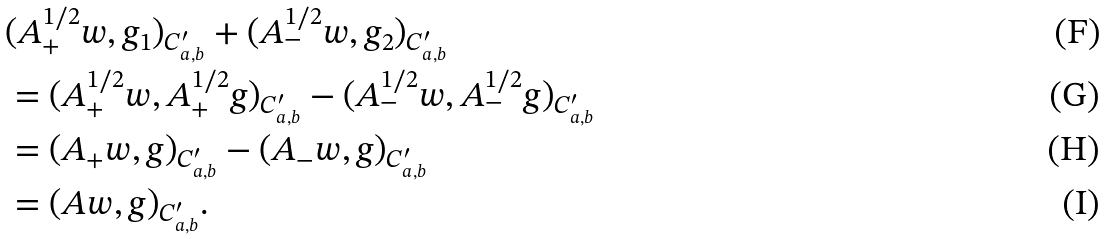<formula> <loc_0><loc_0><loc_500><loc_500>& ( A _ { + } ^ { 1 / 2 } w , g _ { 1 } ) _ { C _ { a , b } ^ { \prime } } + ( A _ { - } ^ { 1 / 2 } w , g _ { 2 } ) _ { C _ { a , b } ^ { \prime } } \\ & = ( A _ { + } ^ { 1 / 2 } w , A _ { + } ^ { 1 / 2 } g ) _ { C _ { a , b } ^ { \prime } } - ( A _ { - } ^ { 1 / 2 } w , A _ { - } ^ { 1 / 2 } g ) _ { C _ { a , b } ^ { \prime } } \\ & = ( A _ { + } w , g ) _ { C _ { a , b } ^ { \prime } } - ( A _ { - } w , g ) _ { C _ { a , b } ^ { \prime } } \\ & = ( A w , g ) _ { C _ { a , b } ^ { \prime } } .</formula> 